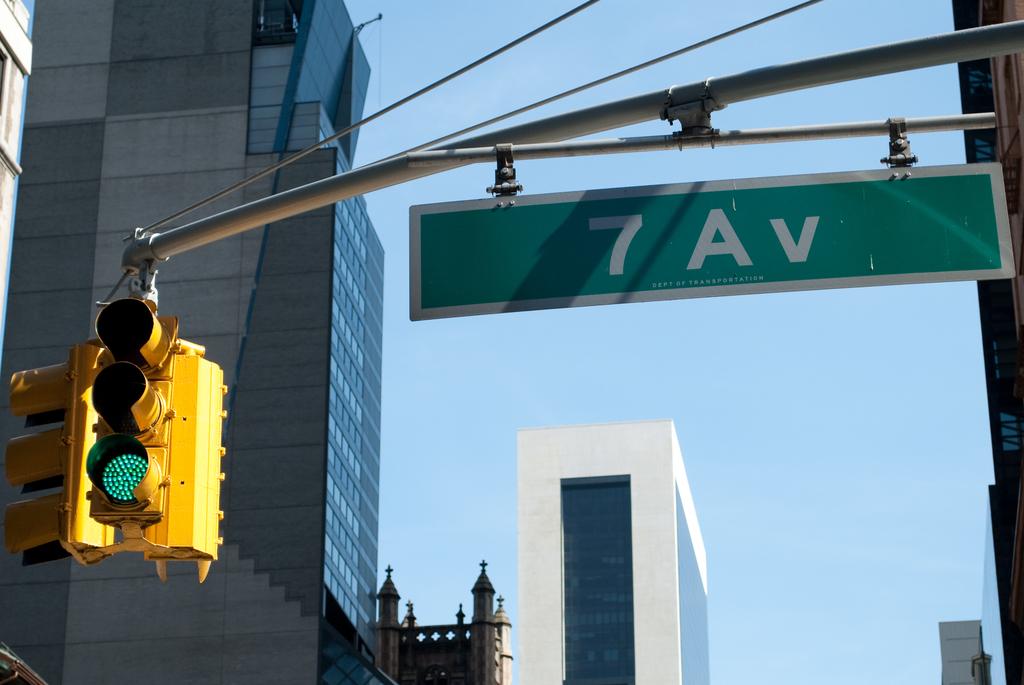What street is this?
Offer a very short reply. 7 av. 